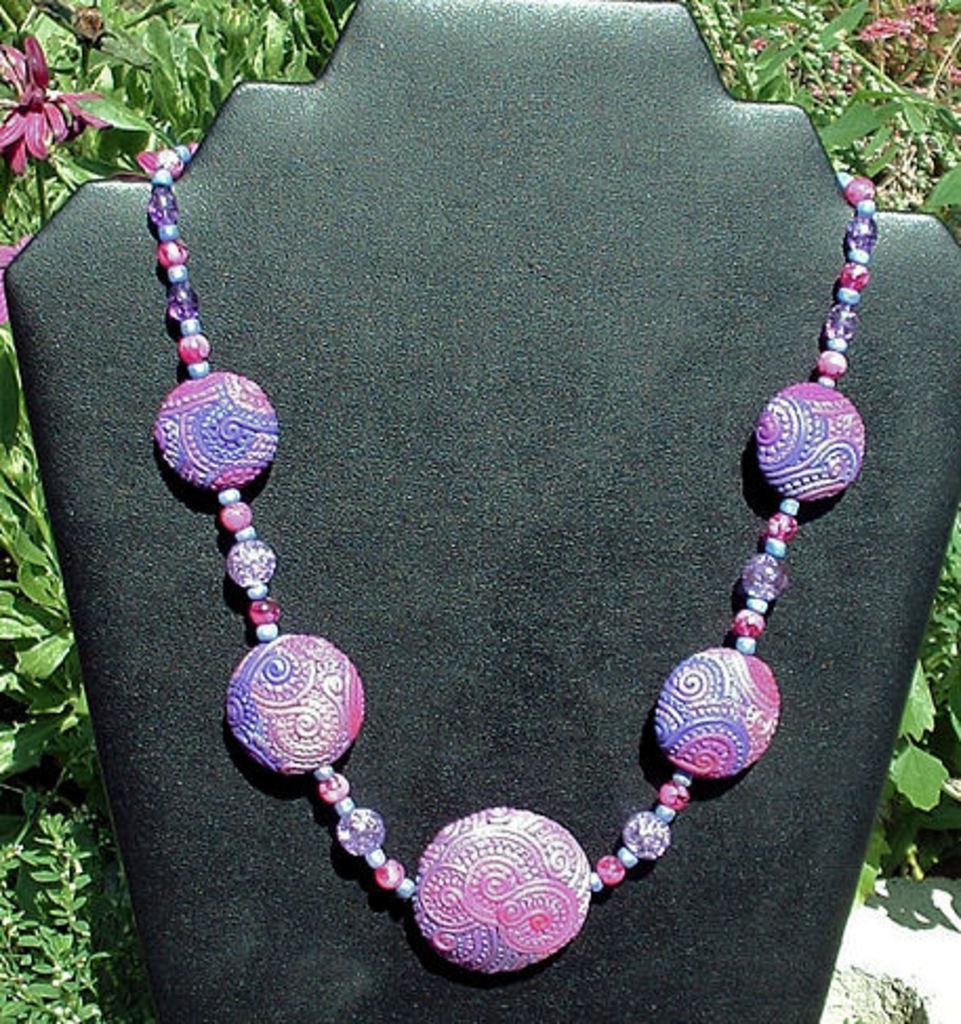Could you give a brief overview of what you see in this image? As we can see in the image there is a necklace with blue and pink color and it is kept on a black color sheet. Behind the sheet there are flowers and leaves. 